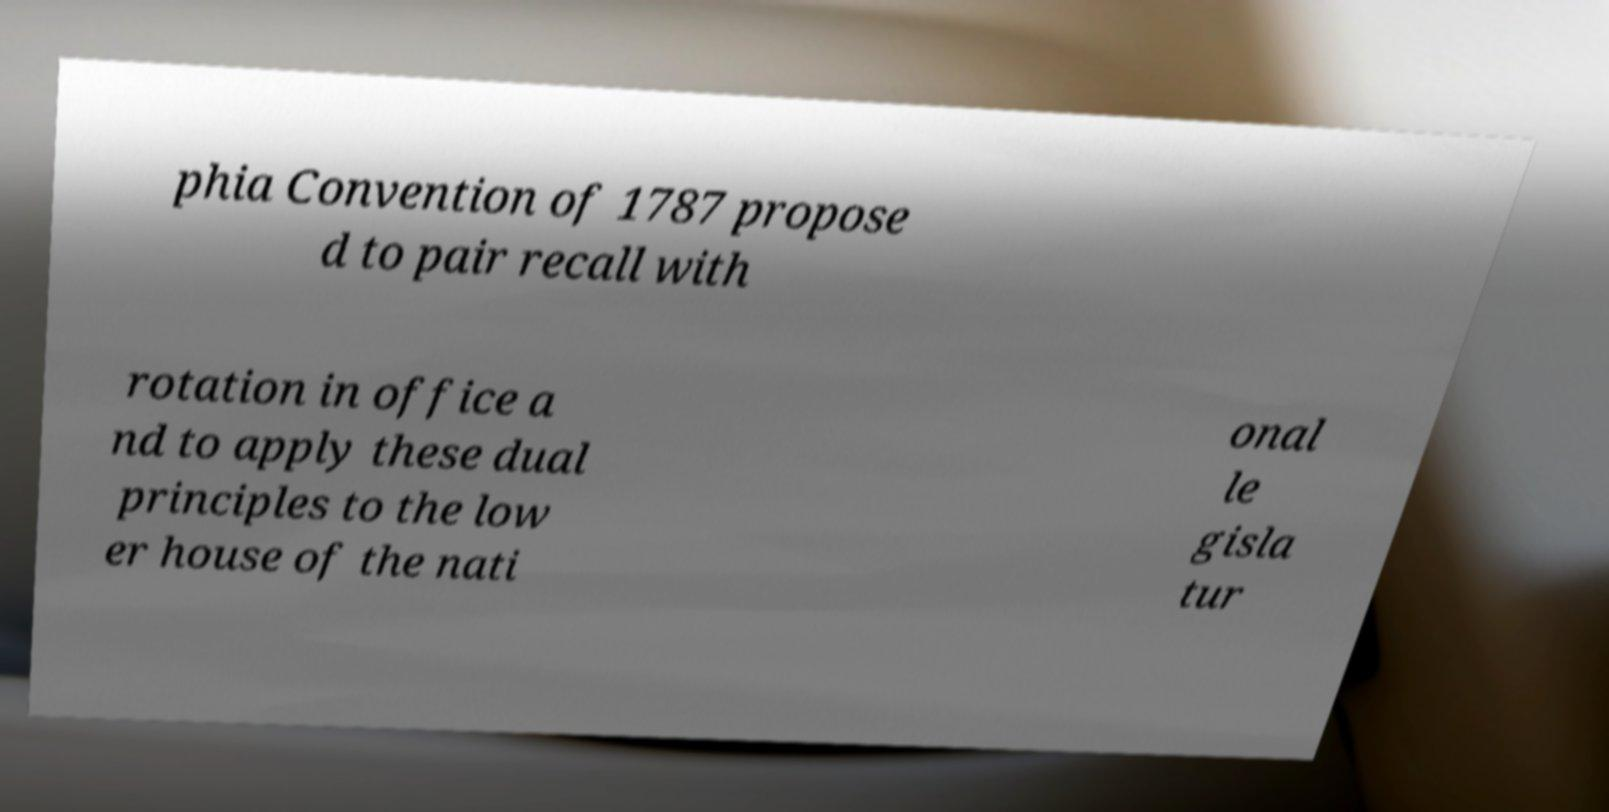Please read and relay the text visible in this image. What does it say? phia Convention of 1787 propose d to pair recall with rotation in office a nd to apply these dual principles to the low er house of the nati onal le gisla tur 